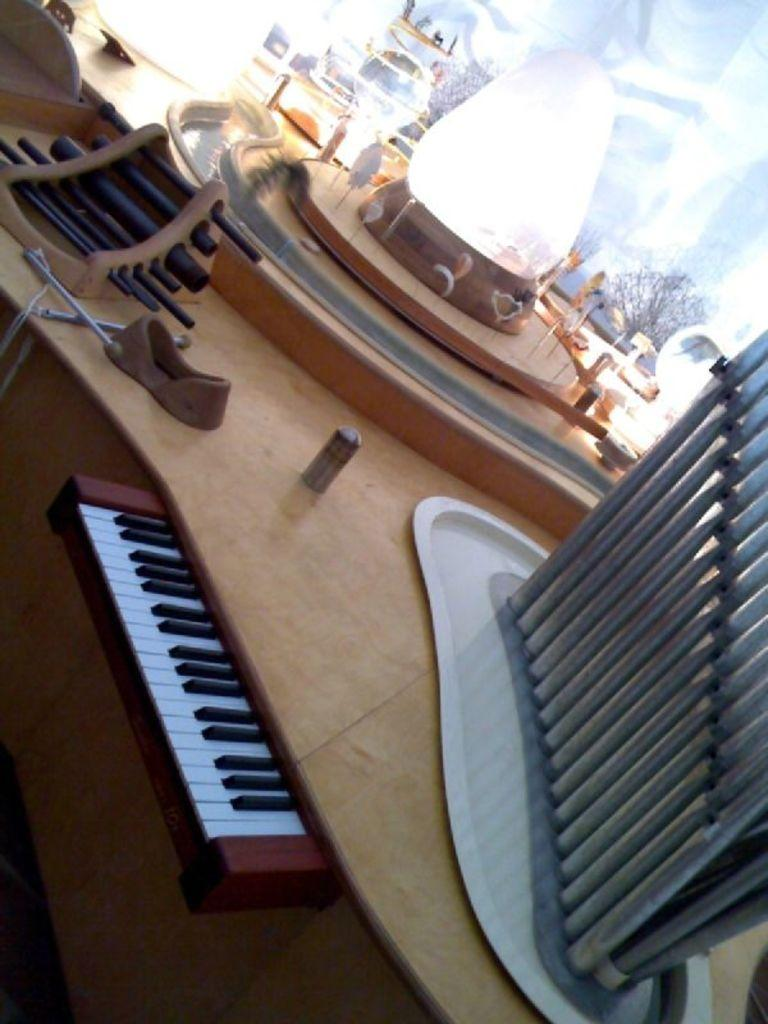What type of musical instrument is visible in the image? There is a piano keyboard with black and white keys in the image. What other musical instruments can be seen in the image? There are musical instruments with rods in the image. What type of tree is present in the image? There is a bare tree in the image. How many bricks are stacked on the piano keyboard in the image? There are no bricks present in the image; it features a piano keyboard and other musical instruments. Can you see a toad sitting on the bare tree in the image? There is no toad present in the image; it only features a piano keyboard, musical instruments, and a bare tree. 